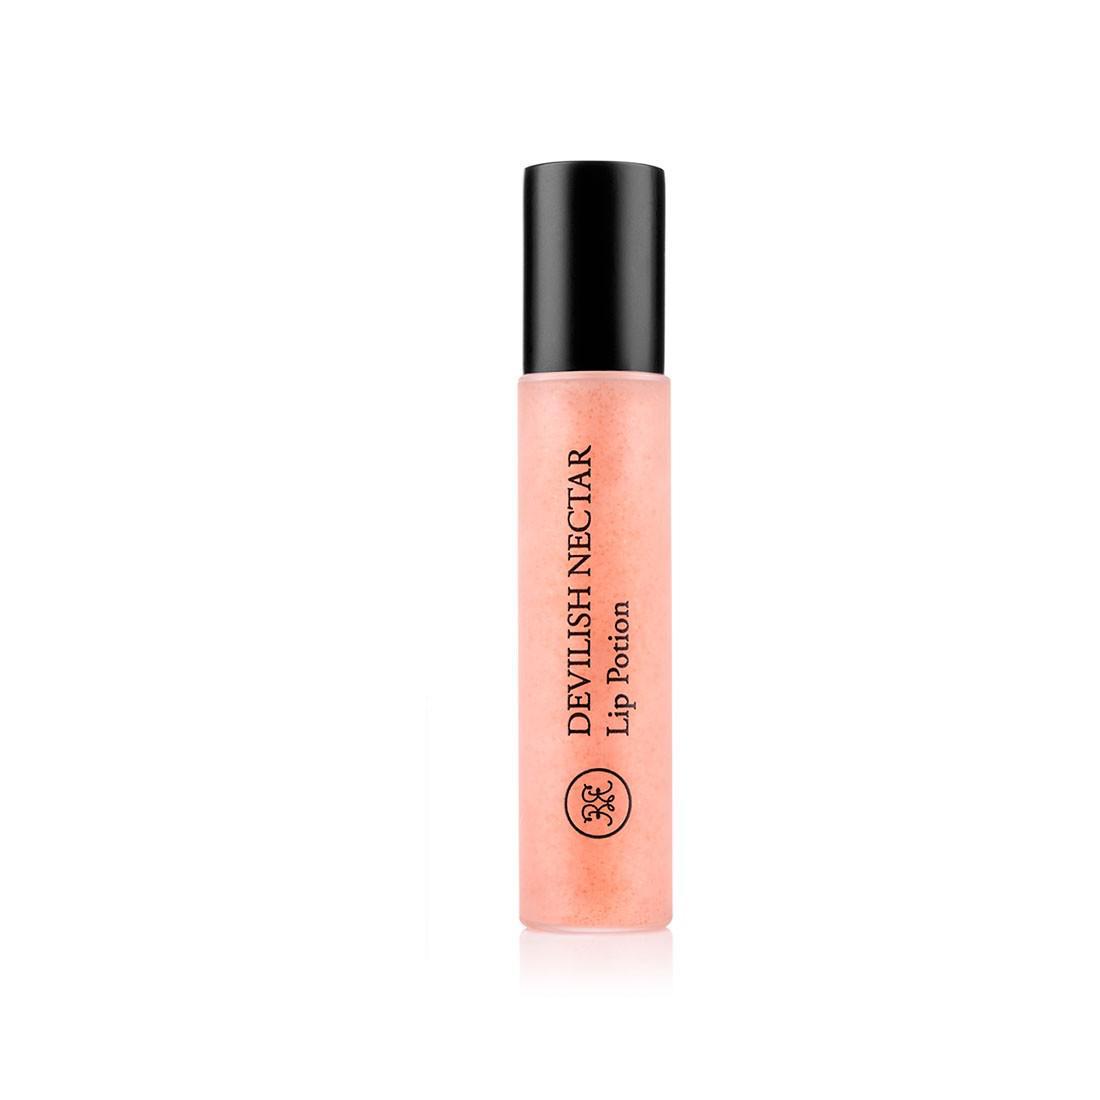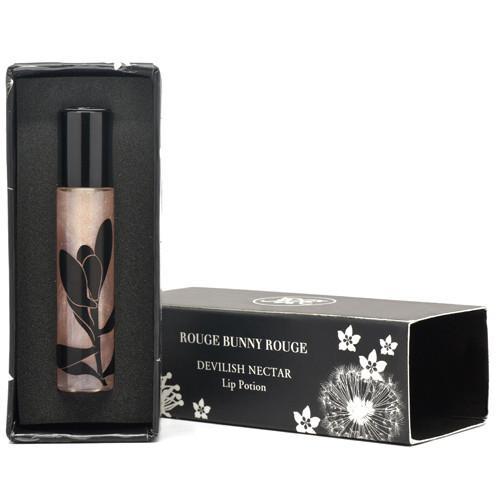The first image is the image on the left, the second image is the image on the right. Assess this claim about the two images: "In the left image, there is a single tube of makeup, and it has a clear body casing.". Correct or not? Answer yes or no. Yes. The first image is the image on the left, the second image is the image on the right. Evaluate the accuracy of this statement regarding the images: "There are at least eight lip products in total.". Is it true? Answer yes or no. No. 